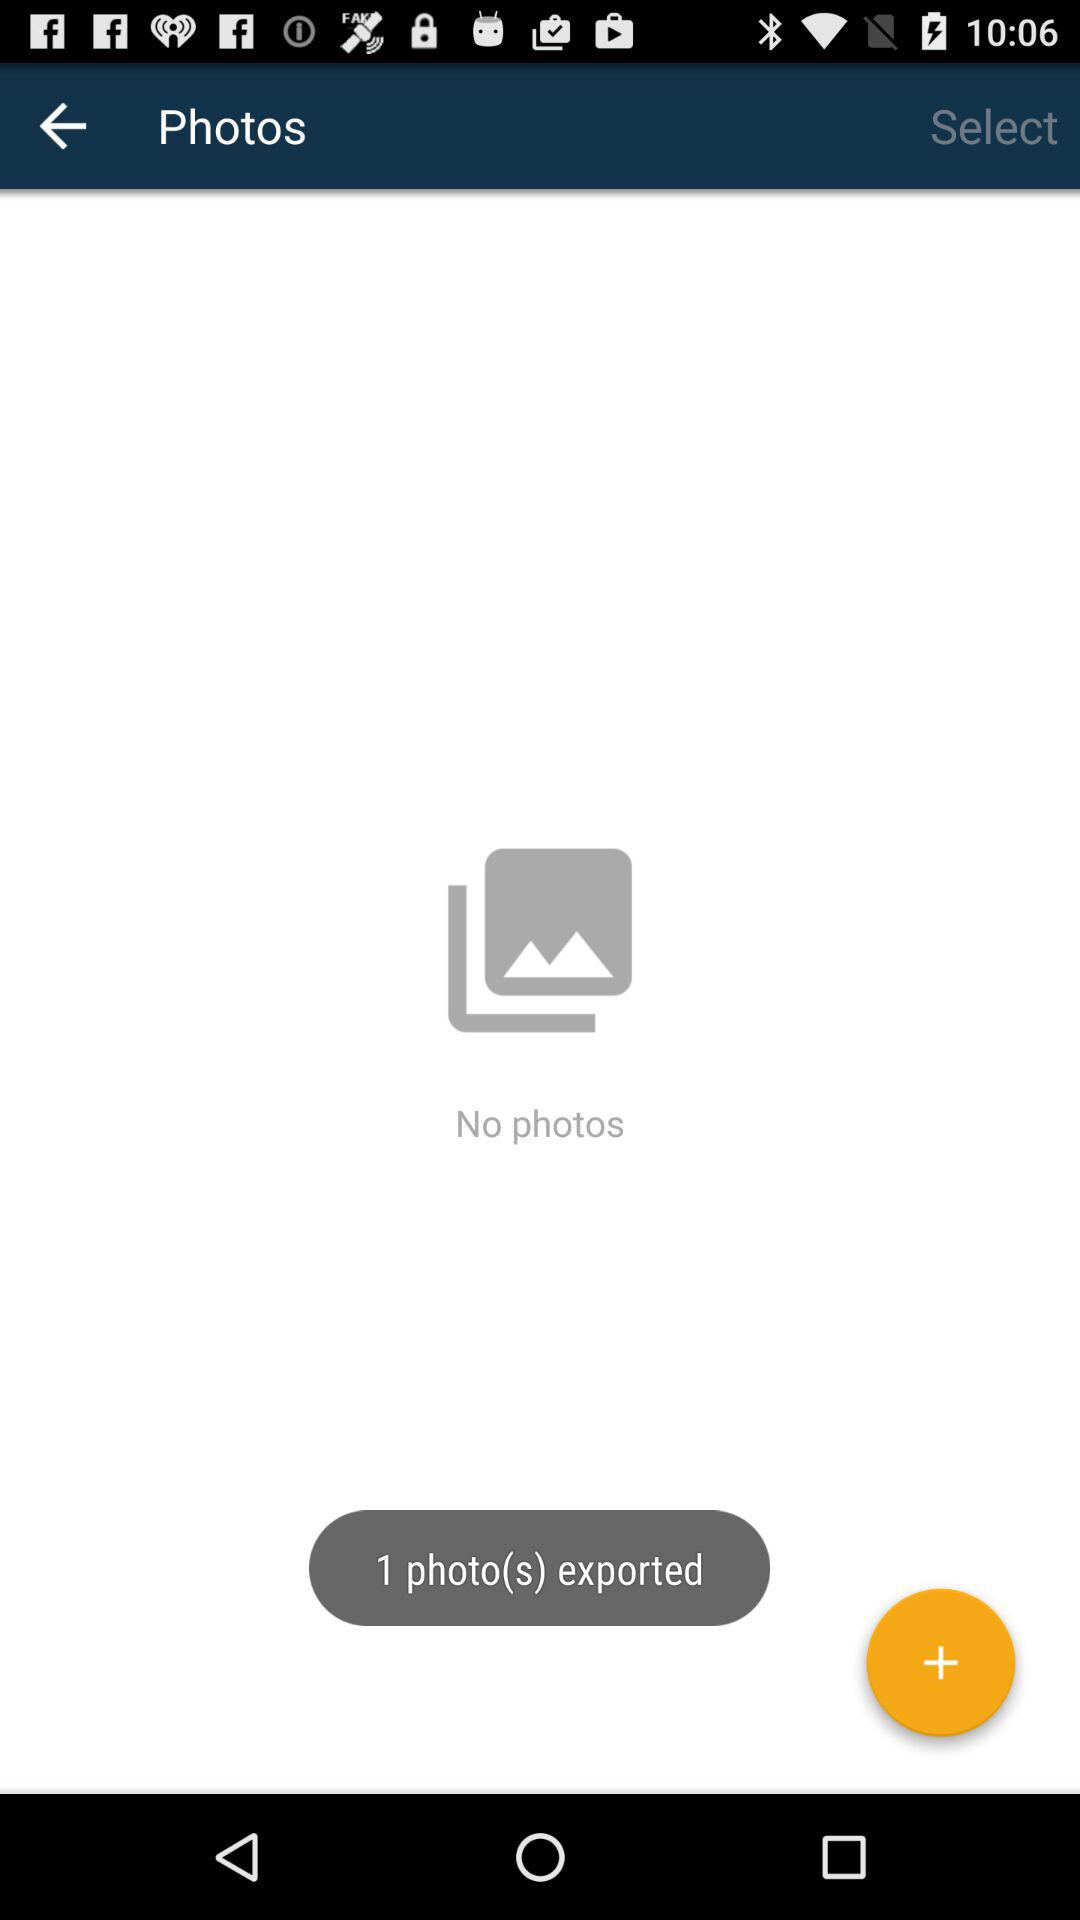How many photos have been exported?
Answer the question using a single word or phrase. 1 